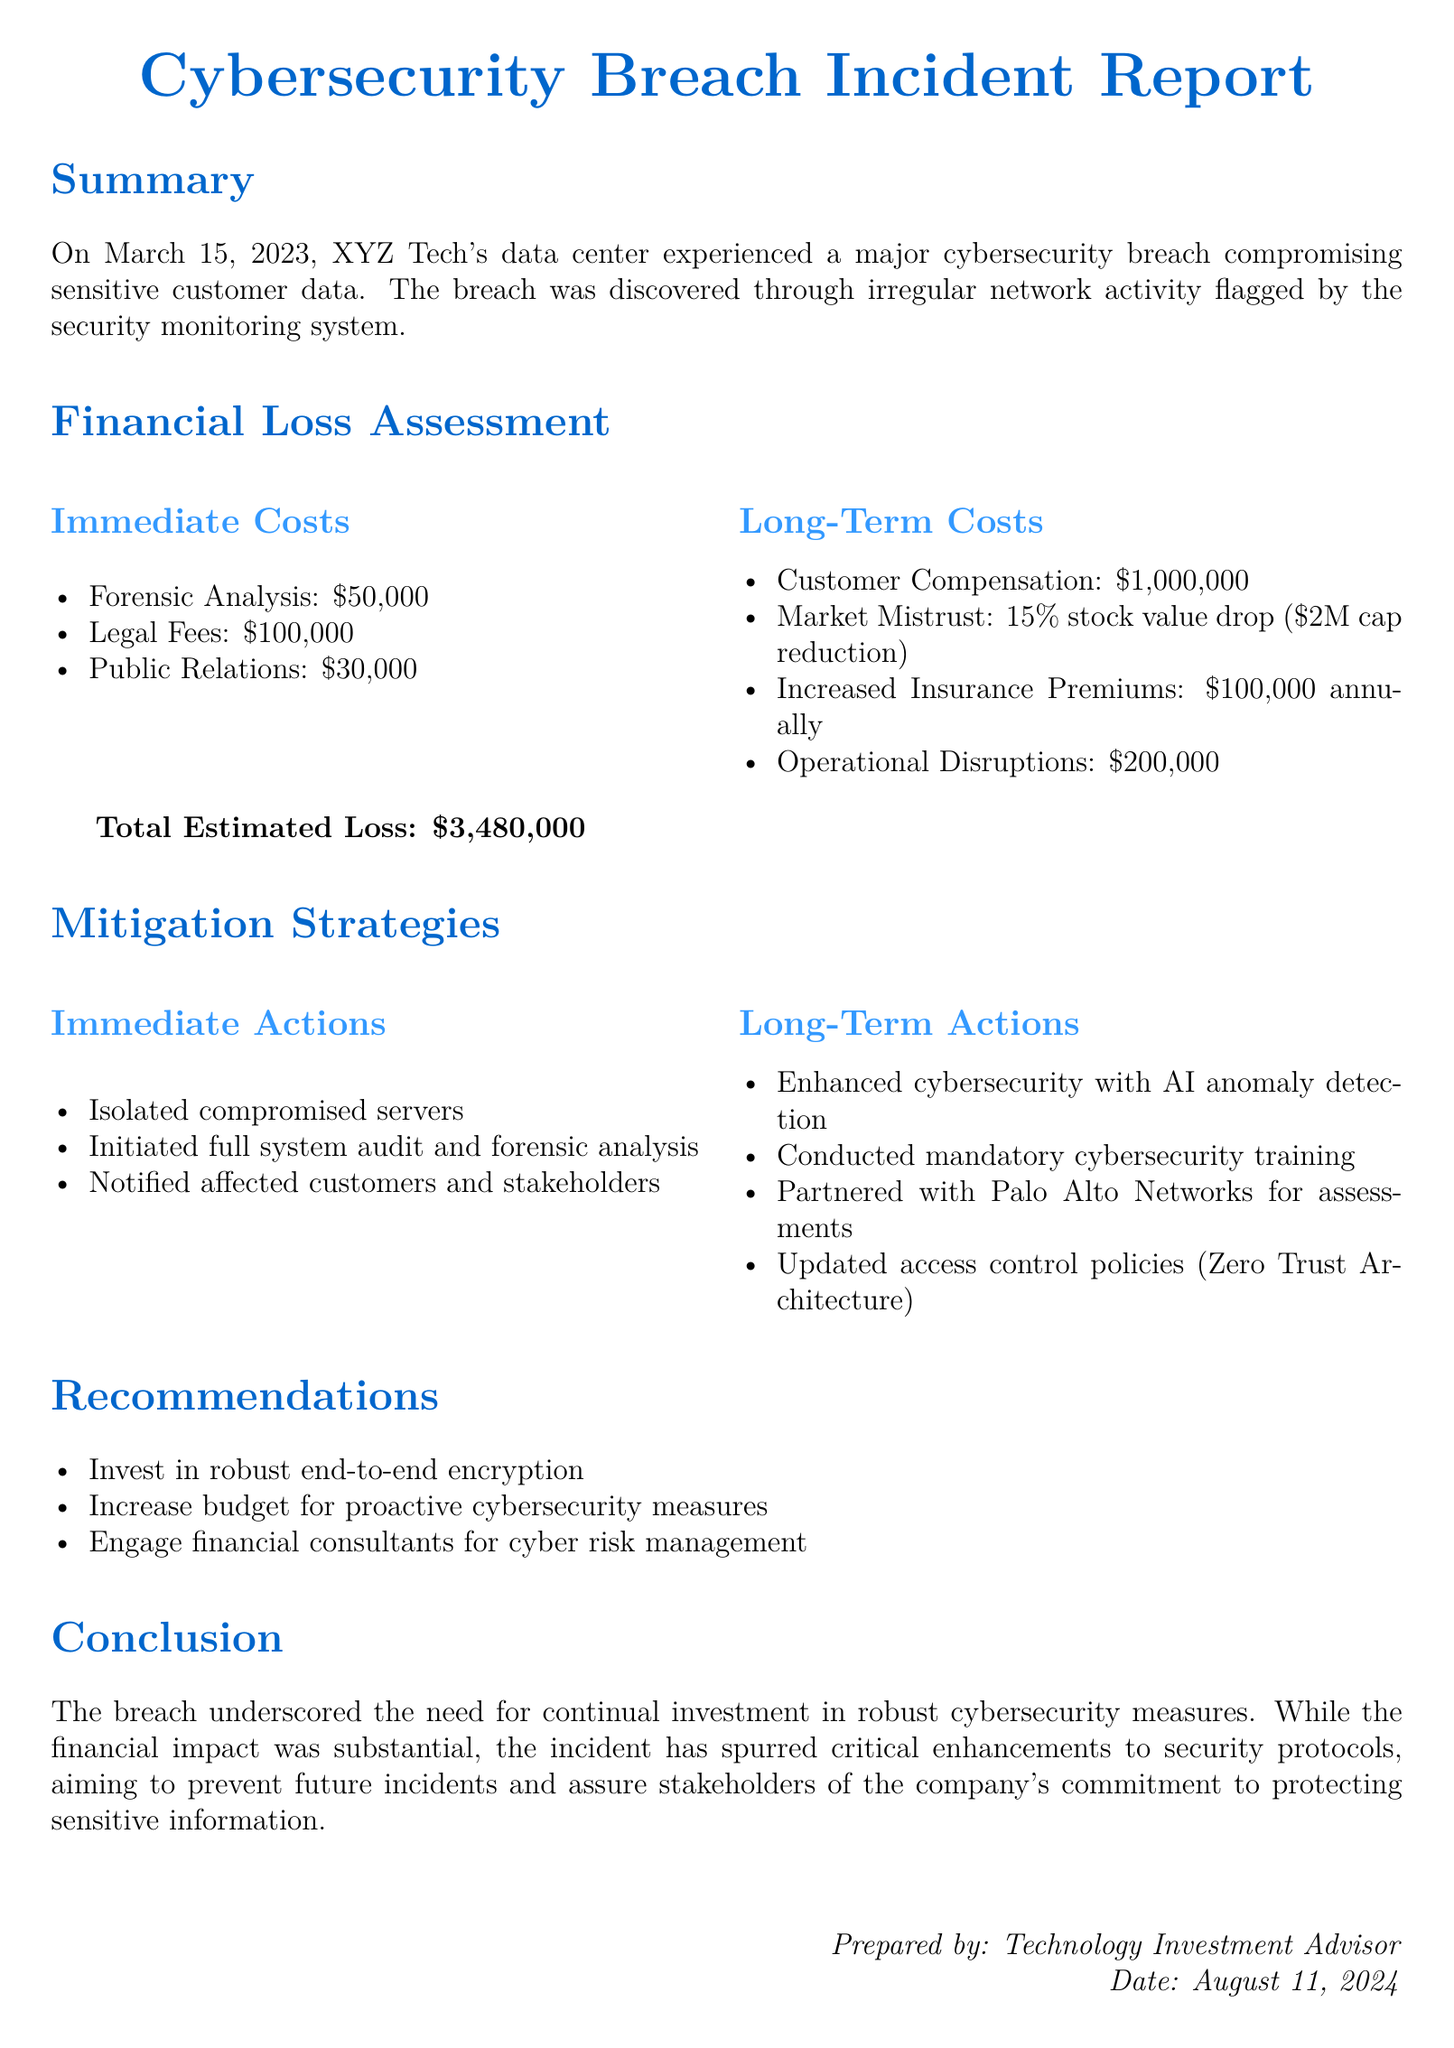What date did the breach occur? The breach was discovered on March 15, 2023, as mentioned in the summary section.
Answer: March 15, 2023 What were the immediate costs of the breach? Immediate costs include forensic analysis, legal fees, and public relations costs, totaling $50,000 + $100,000 + $30,000.
Answer: $180,000 What is the total estimated loss from the breach? The document summarizes the total estimated loss, which aggregates immediate and long-term costs.
Answer: $3,480,000 How much did customer compensation amount to in long-term costs? Customer compensation is specified in the long-term costs section as $1,000,000.
Answer: $1,000,000 What percentage of stock value drop was caused by market mistrust? The market mistrust led to a 15% drop in stock value, as stated in the long-term costs section.
Answer: 15% What long-term action was taken regarding cybersecurity? One of the long-term actions taken was enhancing cybersecurity with AI anomaly detection.
Answer: AI anomaly detection How much are the increased insurance premiums annually as a result of the breach? The document specifies that insurance premiums increased by $100,000 annually.
Answer: $100,000 What organization did XYZ Tech partner with for assessments? The report states that they partnered with Palo Alto Networks for assessments during their response.
Answer: Palo Alto Networks What does the conclusion highlight about necessary investments? The conclusion emphasizes the need for continual investment in robust cybersecurity measures.
Answer: Continual investment in robust cybersecurity measures 